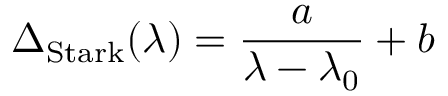Convert formula to latex. <formula><loc_0><loc_0><loc_500><loc_500>\Delta _ { S t a r k } ( \lambda ) = \frac { a } { \lambda - \lambda _ { 0 } } + b</formula> 